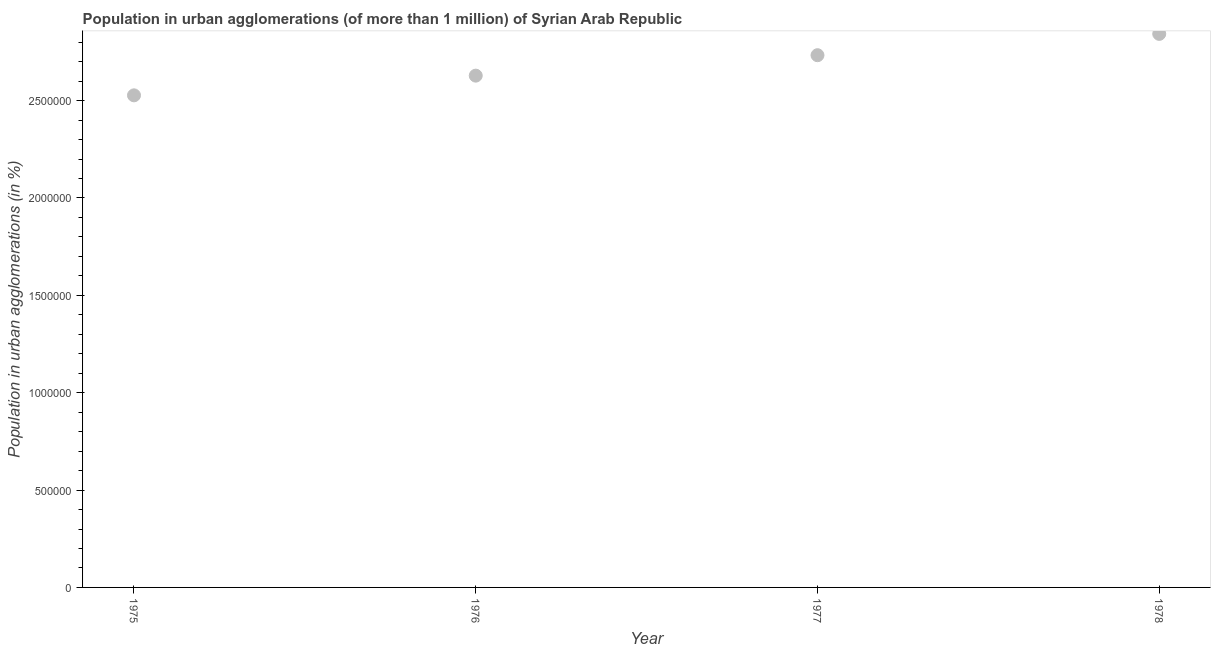What is the population in urban agglomerations in 1975?
Your answer should be compact. 2.53e+06. Across all years, what is the maximum population in urban agglomerations?
Ensure brevity in your answer.  2.84e+06. Across all years, what is the minimum population in urban agglomerations?
Offer a very short reply. 2.53e+06. In which year was the population in urban agglomerations maximum?
Ensure brevity in your answer.  1978. In which year was the population in urban agglomerations minimum?
Your response must be concise. 1975. What is the sum of the population in urban agglomerations?
Offer a very short reply. 1.07e+07. What is the difference between the population in urban agglomerations in 1975 and 1976?
Your response must be concise. -1.01e+05. What is the average population in urban agglomerations per year?
Your answer should be very brief. 2.68e+06. What is the median population in urban agglomerations?
Provide a succinct answer. 2.68e+06. In how many years, is the population in urban agglomerations greater than 2300000 %?
Your answer should be very brief. 4. What is the ratio of the population in urban agglomerations in 1975 to that in 1978?
Your answer should be very brief. 0.89. Is the difference between the population in urban agglomerations in 1977 and 1978 greater than the difference between any two years?
Your answer should be compact. No. What is the difference between the highest and the second highest population in urban agglomerations?
Ensure brevity in your answer.  1.09e+05. What is the difference between the highest and the lowest population in urban agglomerations?
Provide a succinct answer. 3.16e+05. Does the population in urban agglomerations monotonically increase over the years?
Make the answer very short. Yes. What is the title of the graph?
Keep it short and to the point. Population in urban agglomerations (of more than 1 million) of Syrian Arab Republic. What is the label or title of the X-axis?
Offer a very short reply. Year. What is the label or title of the Y-axis?
Keep it short and to the point. Population in urban agglomerations (in %). What is the Population in urban agglomerations (in %) in 1975?
Your answer should be compact. 2.53e+06. What is the Population in urban agglomerations (in %) in 1976?
Provide a short and direct response. 2.63e+06. What is the Population in urban agglomerations (in %) in 1977?
Your response must be concise. 2.73e+06. What is the Population in urban agglomerations (in %) in 1978?
Your answer should be very brief. 2.84e+06. What is the difference between the Population in urban agglomerations (in %) in 1975 and 1976?
Make the answer very short. -1.01e+05. What is the difference between the Population in urban agglomerations (in %) in 1975 and 1977?
Offer a terse response. -2.06e+05. What is the difference between the Population in urban agglomerations (in %) in 1975 and 1978?
Give a very brief answer. -3.16e+05. What is the difference between the Population in urban agglomerations (in %) in 1976 and 1977?
Give a very brief answer. -1.05e+05. What is the difference between the Population in urban agglomerations (in %) in 1976 and 1978?
Make the answer very short. -2.14e+05. What is the difference between the Population in urban agglomerations (in %) in 1977 and 1978?
Your response must be concise. -1.09e+05. What is the ratio of the Population in urban agglomerations (in %) in 1975 to that in 1977?
Offer a terse response. 0.93. What is the ratio of the Population in urban agglomerations (in %) in 1975 to that in 1978?
Provide a succinct answer. 0.89. What is the ratio of the Population in urban agglomerations (in %) in 1976 to that in 1978?
Your answer should be very brief. 0.93. 